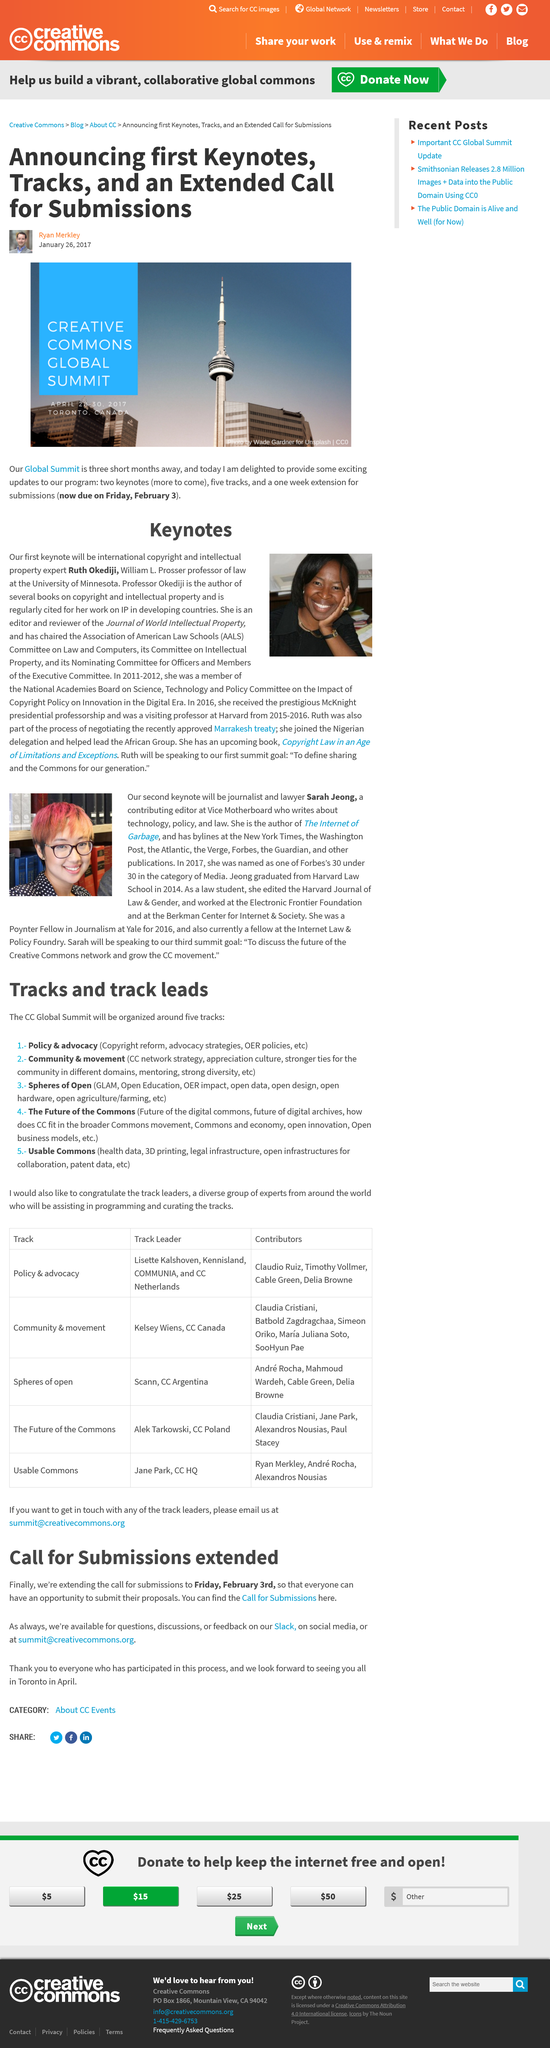Indicate a few pertinent items in this graphic. There is an extended call for submissions at this summit. The submissions are due by Friday, February 3rd. The Creative Commons Global Summit is being reported on by Ryan Merkley. 